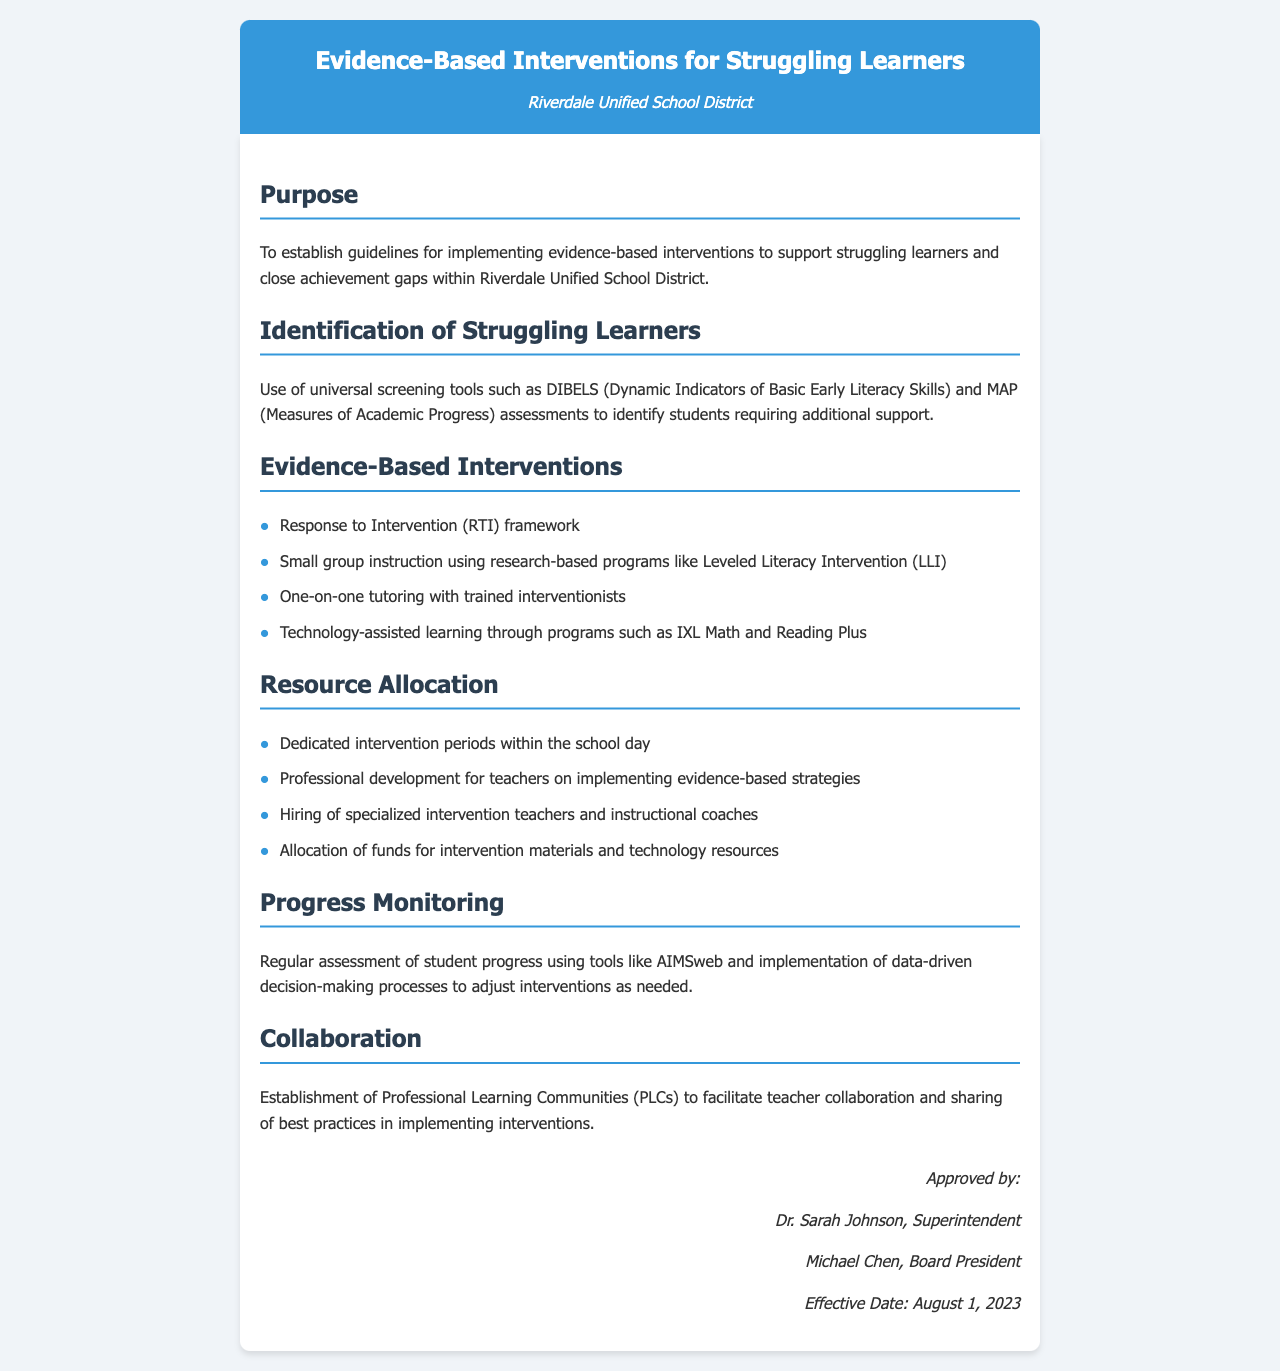What is the purpose of the document? The purpose is stated in the first section, which establishes guidelines for implementing evidence-based interventions to support struggling learners.
Answer: To establish guidelines for implementing evidence-based interventions to support struggling learners and close achievement gaps within Riverdale Unified School District What tools are used for screening? The document specifies the universal screening tools included in the identification section used for identifying students needing support.
Answer: DIBELS and MAP What intervention framework is mentioned? The evidence-based interventions section includes a specific framework used for providing interventions to learners.
Answer: Response to Intervention (RTI) framework What is one of the professional development focuses? The resource allocation section describes the focus of professional development for teachers related to intervention strategies.
Answer: Implementing evidence-based strategies Who approved the document? The approval section lists the individuals responsible for approving the document.
Answer: Dr. Sarah Johnson, Superintendent How often is student progress monitored? The progress monitoring section references the regularity of progress check-ups for students, indicating it is ongoing.
Answer: Regular assessment What date does the policy take effect? The document includes an effective date in the approval section.
Answer: August 1, 2023 Which instructional program is used for small group instruction? The evidence-based interventions section lists a specific program used for small group instruction aimed at improving literacy.
Answer: Leveled Literacy Intervention (LLI) 